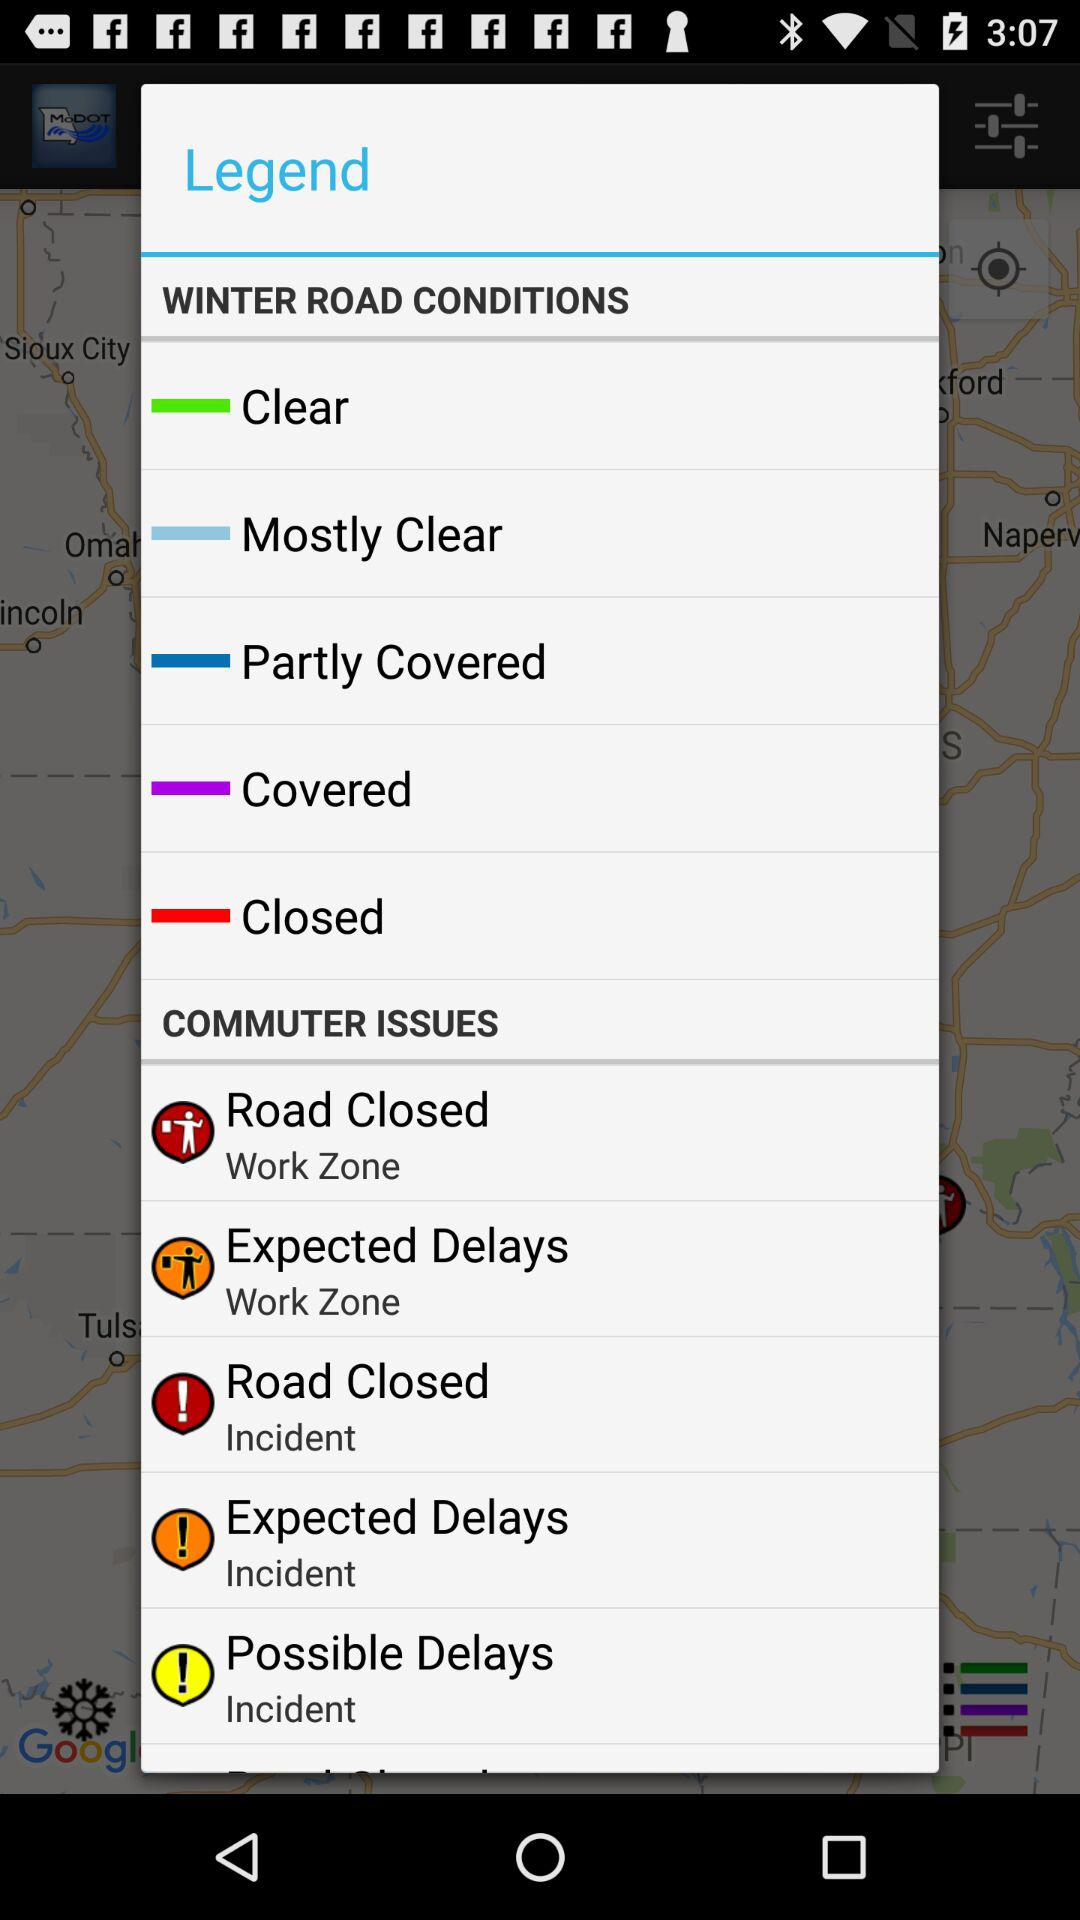How many of the commute issues are not closed?
Answer the question using a single word or phrase. 3 